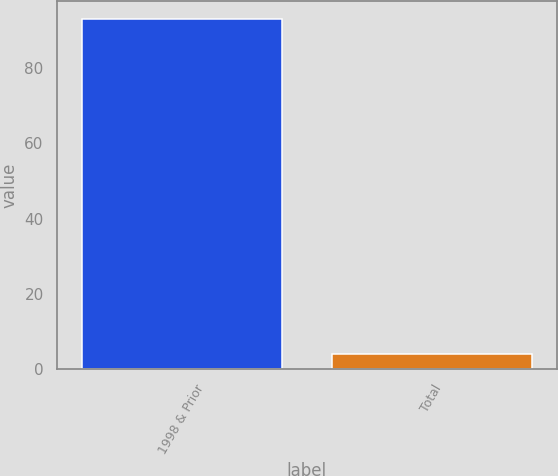Convert chart. <chart><loc_0><loc_0><loc_500><loc_500><bar_chart><fcel>1998 & Prior<fcel>Total<nl><fcel>93<fcel>4<nl></chart> 